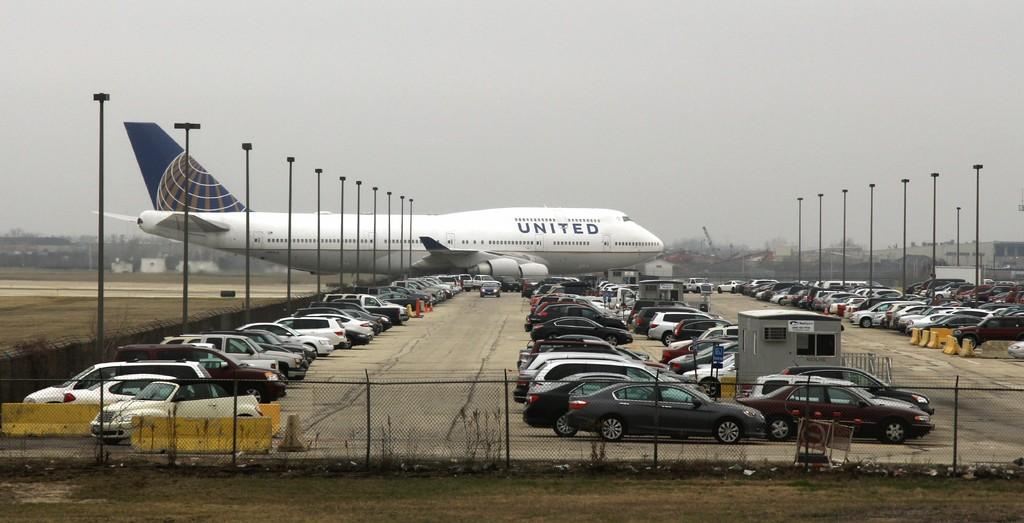<image>
Present a compact description of the photo's key features. A United Airlines plane taxis behind a large parking lot. 